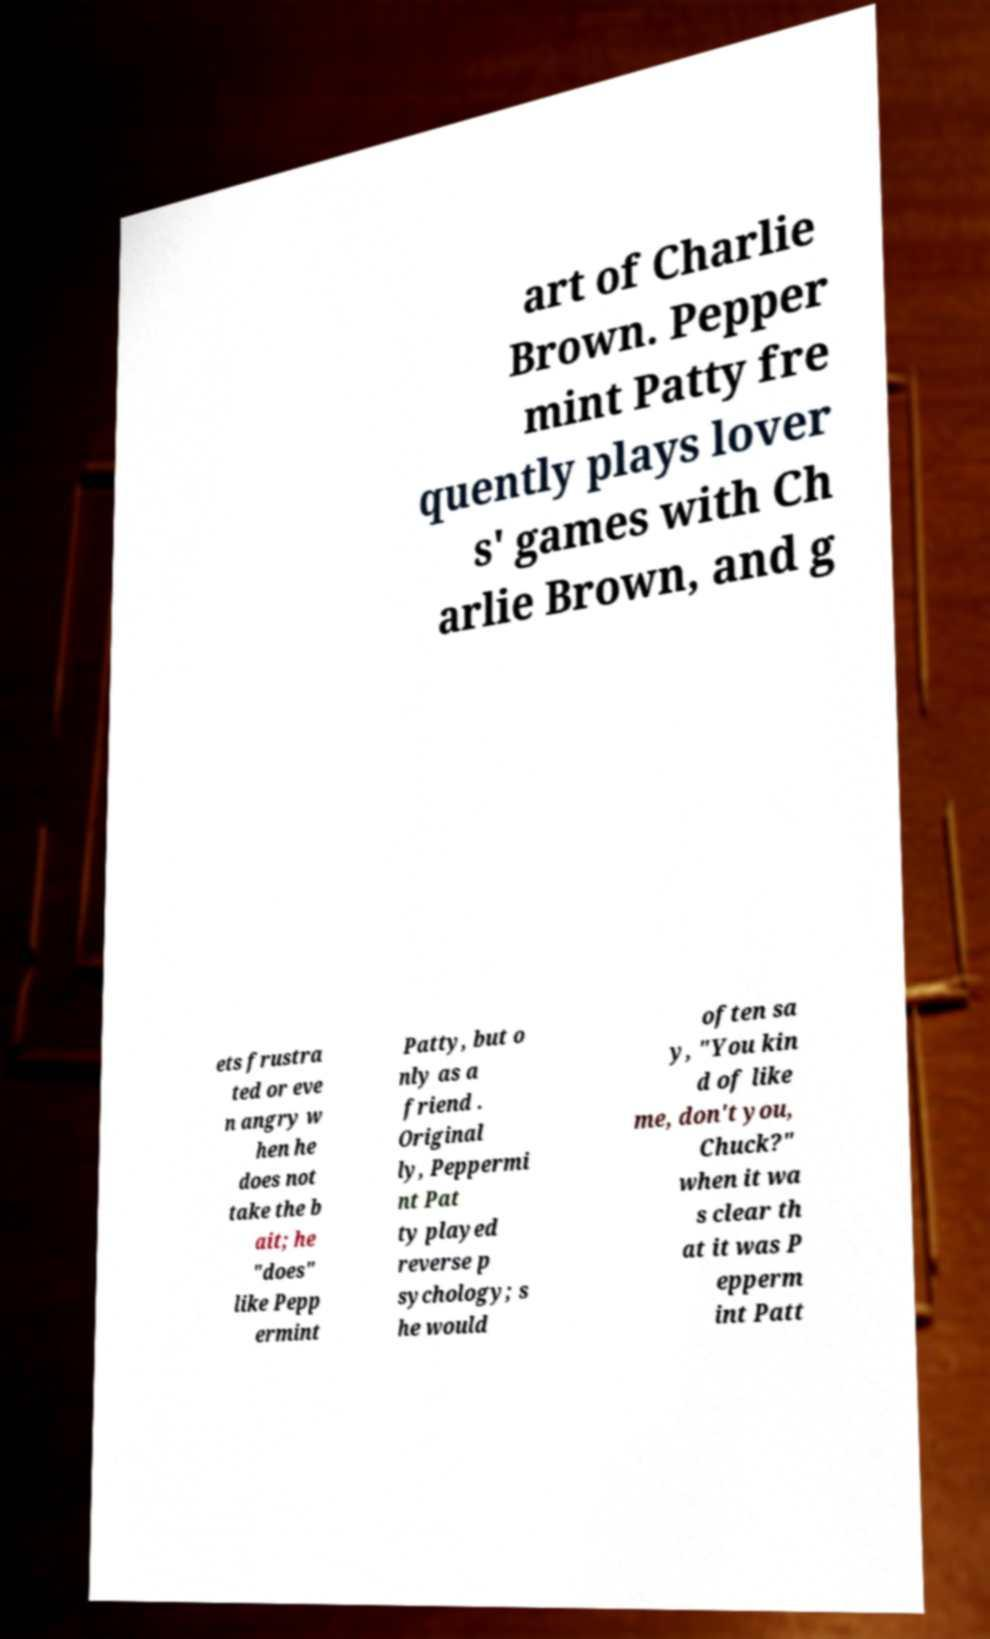Can you read and provide the text displayed in the image?This photo seems to have some interesting text. Can you extract and type it out for me? art of Charlie Brown. Pepper mint Patty fre quently plays lover s' games with Ch arlie Brown, and g ets frustra ted or eve n angry w hen he does not take the b ait; he "does" like Pepp ermint Patty, but o nly as a friend . Original ly, Peppermi nt Pat ty played reverse p sychology; s he would often sa y, "You kin d of like me, don't you, Chuck?" when it wa s clear th at it was P epperm int Patt 